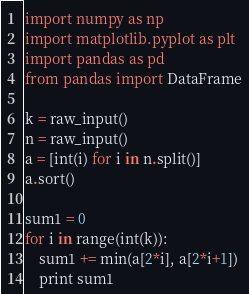<code> <loc_0><loc_0><loc_500><loc_500><_Python_>import numpy as np
import matplotlib.pyplot as plt
import pandas as pd
from pandas import DataFrame

k = raw_input()
n = raw_input()
a = [int(i) for i in n.split()]
a.sort()

sum1 = 0
for i in range(int(k)):
    sum1 += min(a[2*i], a[2*i+1])
    print sum1</code> 